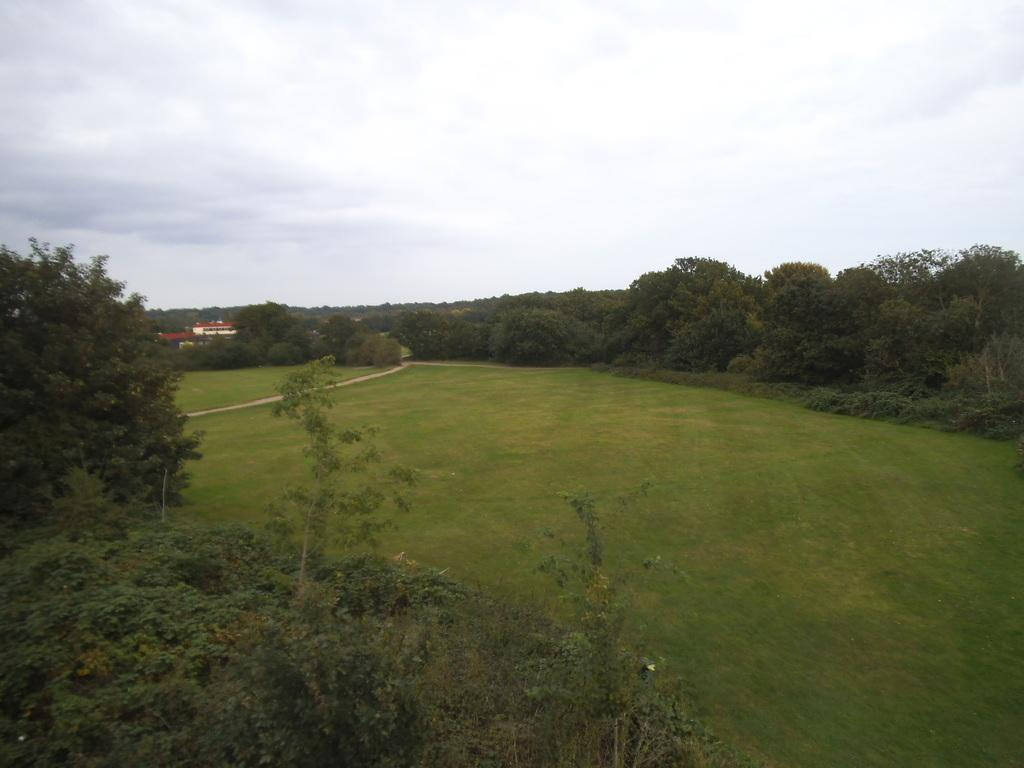What type of landscape is depicted in the image? There is a green field in the image. What can be seen in the distance behind the green field? There are trees and a house in the background of the image. What is visible above the green field and trees? The sky is visible in the image. Where are the trees located in relation to the green field? There are trees on the left side of the image. What type of hammer is being used to build the house in the image? There is no hammer or construction activity depicted in the image; it shows a house in the background of a green field and trees. 